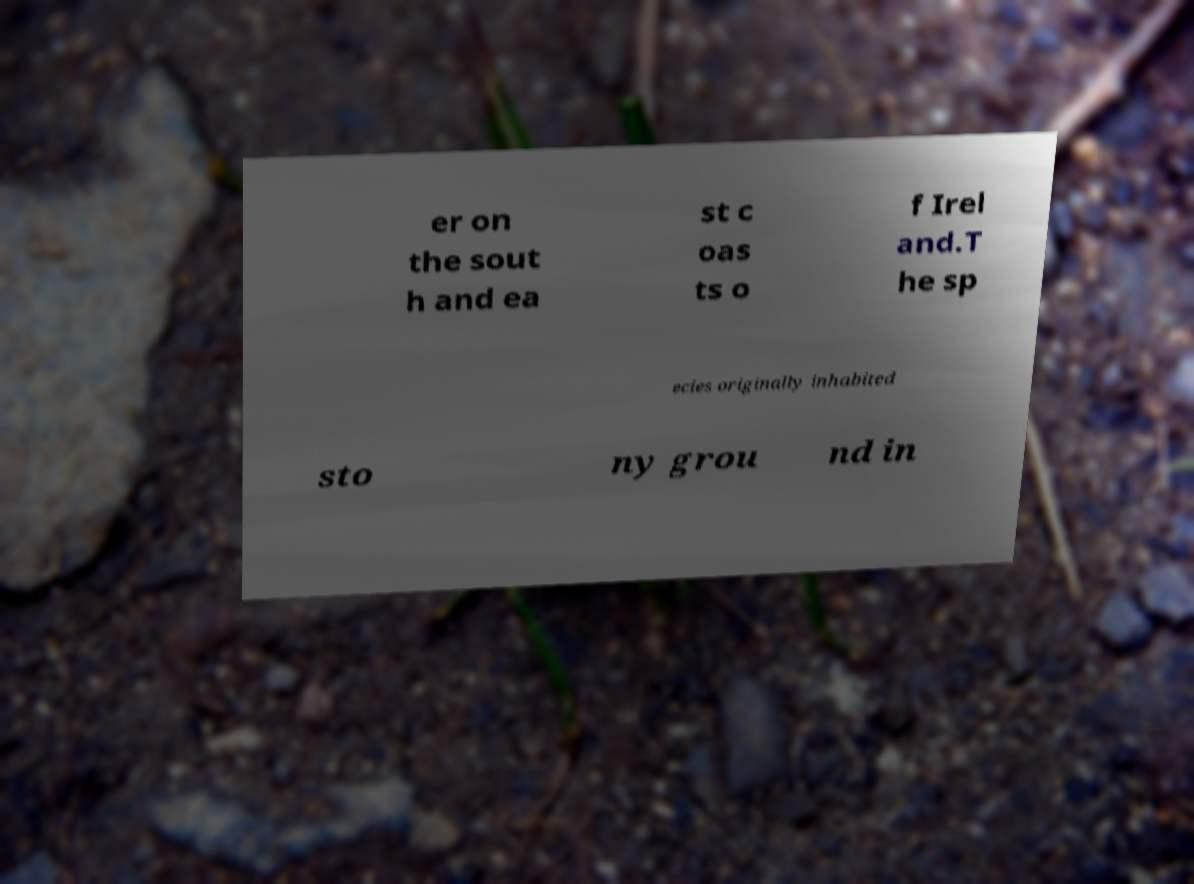Could you assist in decoding the text presented in this image and type it out clearly? er on the sout h and ea st c oas ts o f Irel and.T he sp ecies originally inhabited sto ny grou nd in 